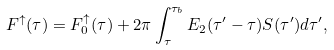Convert formula to latex. <formula><loc_0><loc_0><loc_500><loc_500>F ^ { \uparrow } ( \tau ) = F _ { 0 } ^ { \uparrow } ( \tau ) + 2 \pi \int _ { \tau } ^ { \tau _ { b } } E _ { 2 } ( \tau ^ { \prime } - \tau ) S ( \tau ^ { \prime } ) d \tau ^ { \prime } ,</formula> 